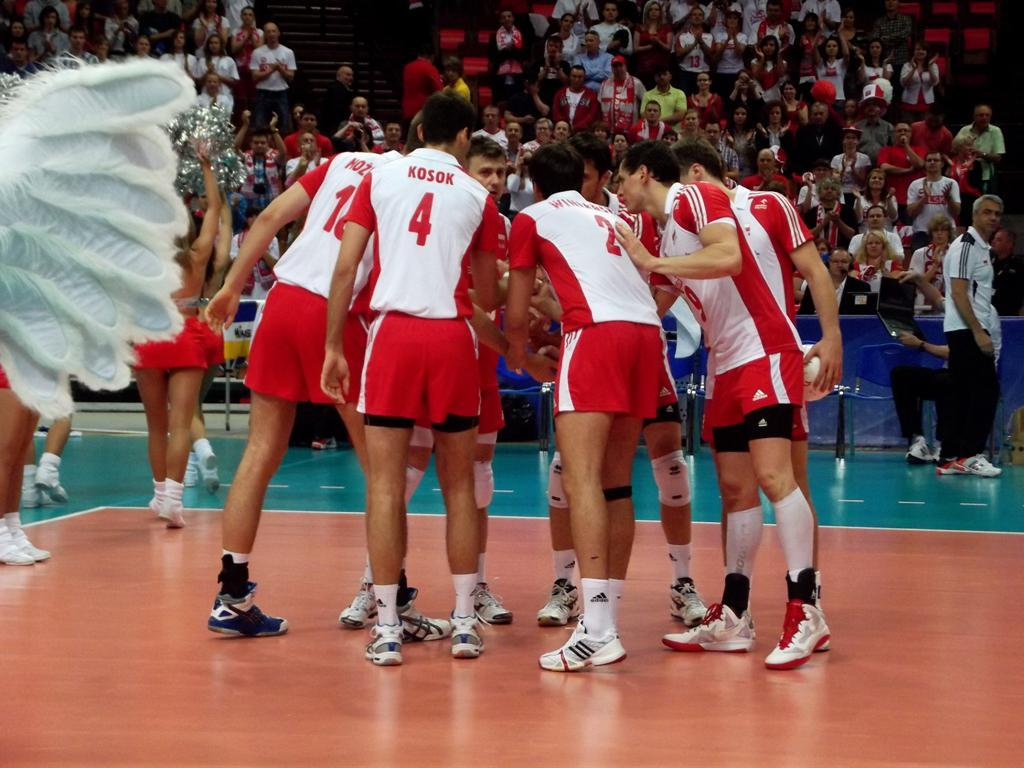<image>
Present a compact description of the photo's key features. Athletes huddle together, including one whose name is Kosok. 